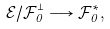Convert formula to latex. <formula><loc_0><loc_0><loc_500><loc_500>\mathcal { E } / \mathcal { F } _ { 0 } ^ { \perp } \longrightarrow \mathcal { F } _ { 0 } ^ { \ast } ,</formula> 